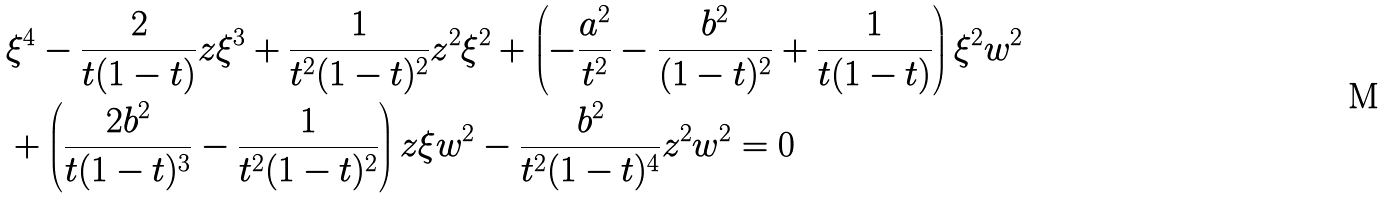Convert formula to latex. <formula><loc_0><loc_0><loc_500><loc_500>& \xi ^ { 4 } - \frac { 2 } { t ( 1 - t ) } z \xi ^ { 3 } + \frac { 1 } { t ^ { 2 } ( 1 - t ) ^ { 2 } } z ^ { 2 } \xi ^ { 2 } + \left ( - \frac { a ^ { 2 } } { t ^ { 2 } } - \frac { b ^ { 2 } } { ( 1 - t ) ^ { 2 } } + \frac { 1 } { t ( 1 - t ) } \right ) \xi ^ { 2 } w ^ { 2 } \\ & + \left ( \frac { 2 b ^ { 2 } } { t ( 1 - t ) ^ { 3 } } - \frac { 1 } { t ^ { 2 } ( 1 - t ) ^ { 2 } } \right ) z \xi w ^ { 2 } - \frac { b ^ { 2 } } { t ^ { 2 } ( 1 - t ) ^ { 4 } } z ^ { 2 } w ^ { 2 } = 0</formula> 